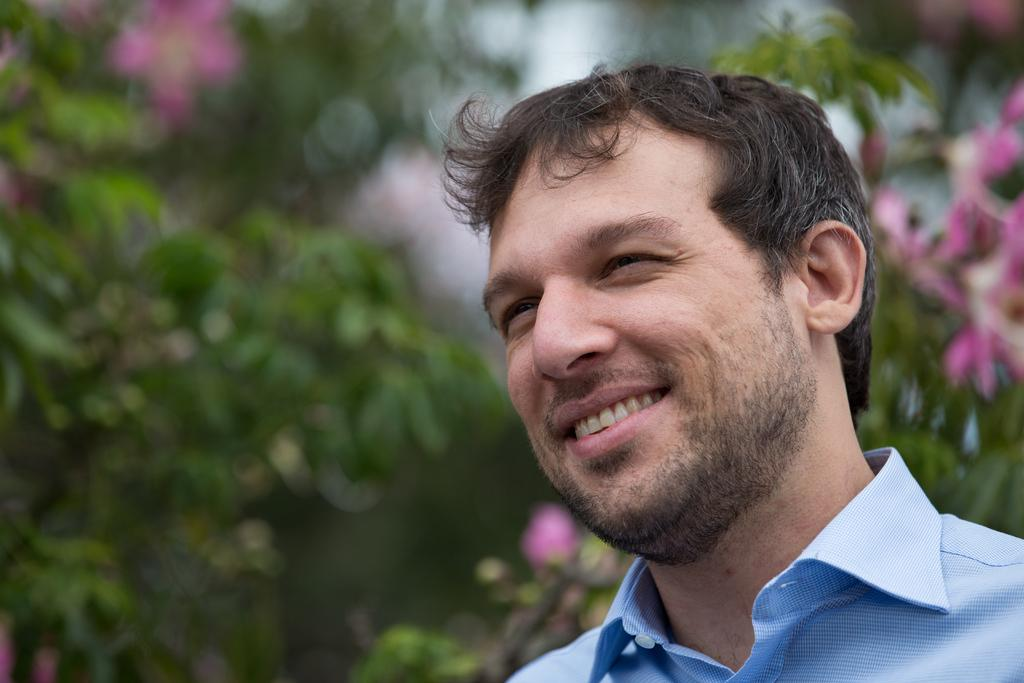Who is present in the image? There is a man in the image. What is the man's facial expression? The man is smiling. What color is the background of the image? The background of the image is blue. What type of natural elements can be seen in the background? There is greenery and flowers in the background. What type of potato is being washed at the faucet in the image? There is no potato or faucet present in the image. What kind of pain is the man experiencing in the image? There is no indication of pain in the image; the man is smiling. 